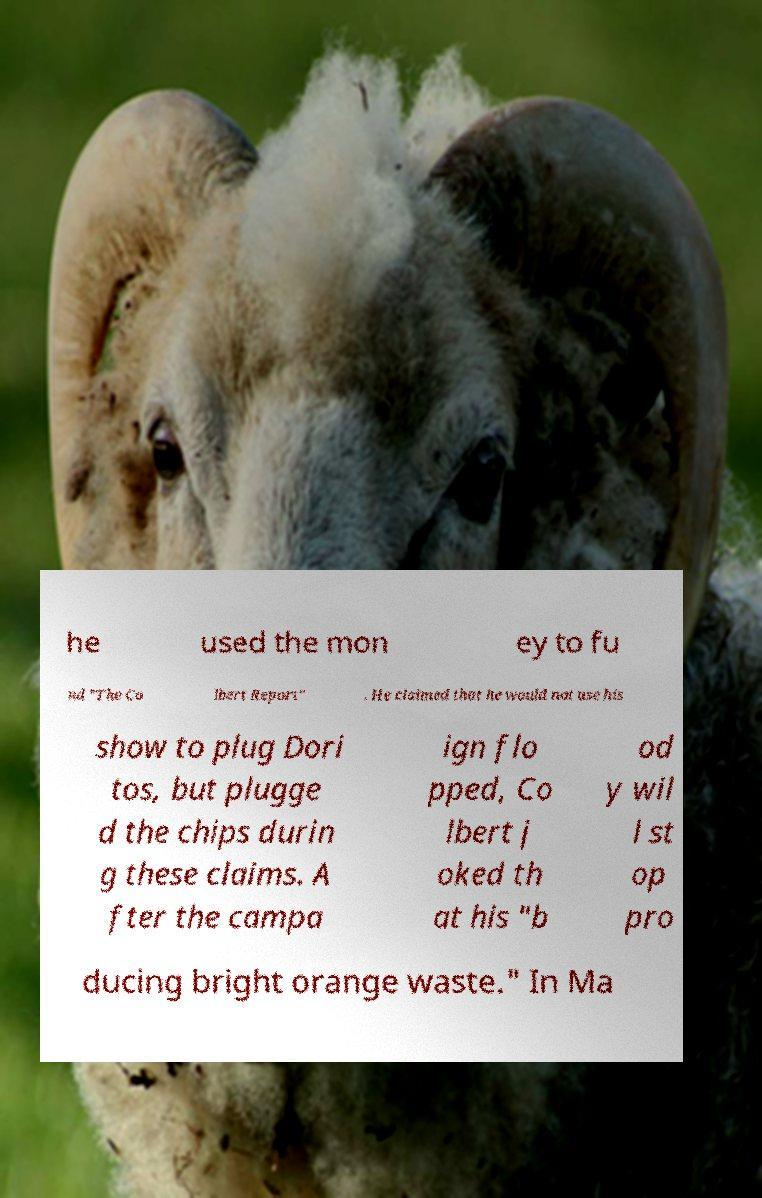Please read and relay the text visible in this image. What does it say? he used the mon ey to fu nd "The Co lbert Report" . He claimed that he would not use his show to plug Dori tos, but plugge d the chips durin g these claims. A fter the campa ign flo pped, Co lbert j oked th at his "b od y wil l st op pro ducing bright orange waste." In Ma 